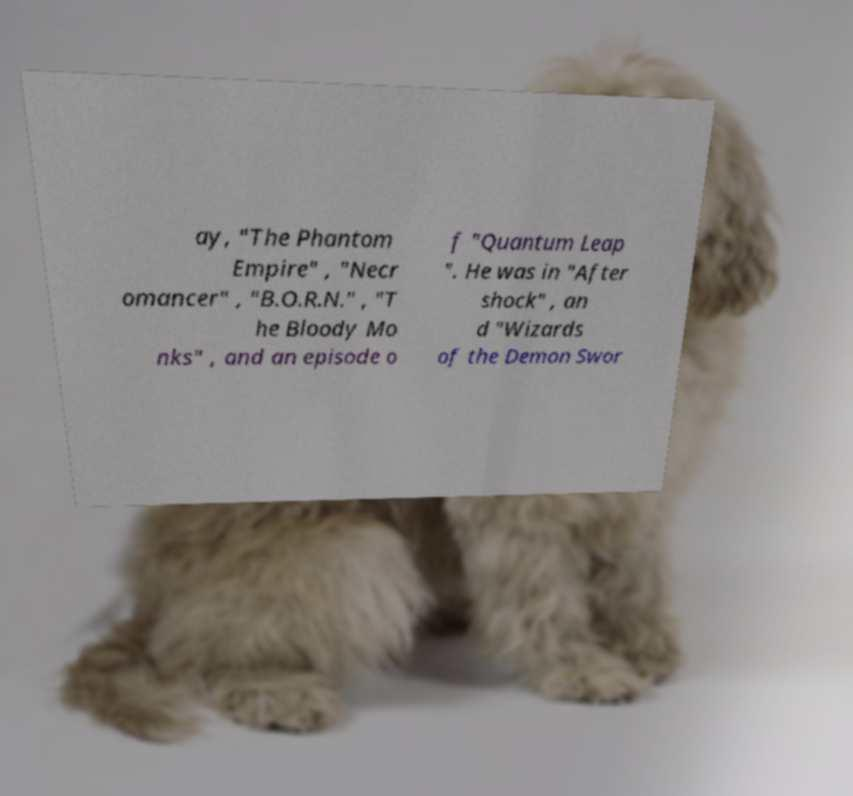There's text embedded in this image that I need extracted. Can you transcribe it verbatim? ay, "The Phantom Empire" , "Necr omancer" , "B.O.R.N." , "T he Bloody Mo nks" , and an episode o f "Quantum Leap ". He was in "After shock" , an d "Wizards of the Demon Swor 